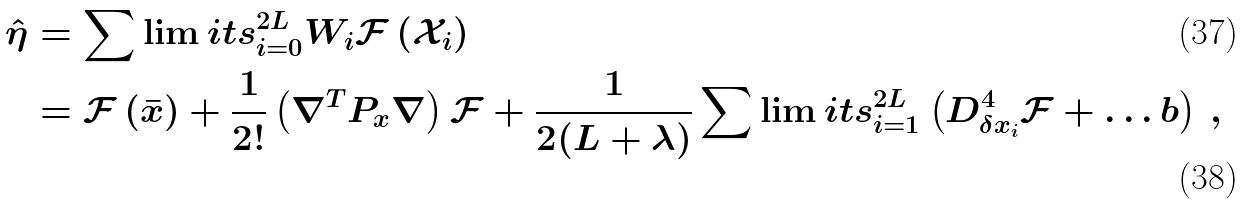Convert formula to latex. <formula><loc_0><loc_0><loc_500><loc_500>\hat { \eta } & = \sum \lim i t s _ { i = 0 } ^ { 2 L } W _ { i } \mathcal { F } \left ( \mathcal { X } _ { i } \right ) \\ & = \mathcal { F } \left ( \bar { x } \right ) + \frac { 1 } { 2 ! } \left ( \nabla ^ { T } P _ { x } \nabla \right ) \mathcal { F } + \frac { 1 } { 2 ( L + \lambda ) } \sum \lim i t s _ { i = 1 } ^ { 2 L } \left ( D _ { \delta x _ { i } } ^ { 4 } \mathcal { F } + \dots b \right ) \, ,</formula> 